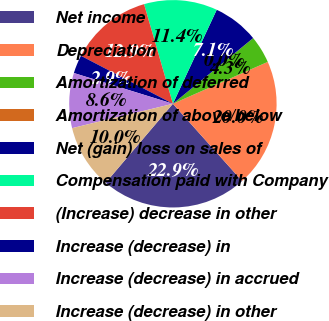Convert chart. <chart><loc_0><loc_0><loc_500><loc_500><pie_chart><fcel>Net income<fcel>Depreciation<fcel>Amortization of deferred<fcel>Amortization of above/below<fcel>Net (gain) loss on sales of<fcel>Compensation paid with Company<fcel>(Increase) decrease in other<fcel>Increase (decrease) in<fcel>Increase (decrease) in accrued<fcel>Increase (decrease) in other<nl><fcel>22.85%<fcel>19.99%<fcel>4.29%<fcel>0.01%<fcel>7.14%<fcel>11.43%<fcel>12.86%<fcel>2.86%<fcel>8.57%<fcel>10.0%<nl></chart> 